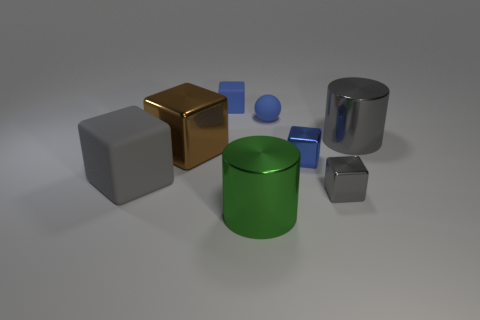The matte object that is the same color as the rubber sphere is what shape?
Provide a succinct answer. Cube. What is the color of the rubber sphere?
Offer a terse response. Blue. What color is the matte ball that is the same size as the blue rubber cube?
Your answer should be compact. Blue. Is there a rubber sphere that has the same color as the tiny rubber block?
Provide a short and direct response. Yes. There is a gray metal thing that is behind the small blue metallic block; is it the same shape as the object that is in front of the small gray thing?
Provide a succinct answer. Yes. There is a metal cylinder that is the same color as the large rubber thing; what is its size?
Offer a very short reply. Large. What number of other things are there of the same size as the green cylinder?
Give a very brief answer. 3. There is a ball; is it the same color as the tiny metallic object that is to the left of the tiny gray metal block?
Your answer should be compact. Yes. Is the number of metallic cylinders behind the tiny blue rubber cube less than the number of gray rubber blocks that are left of the blue metallic object?
Your answer should be compact. Yes. There is a big metallic object that is both behind the large green metal object and left of the small gray object; what color is it?
Your response must be concise. Brown. 